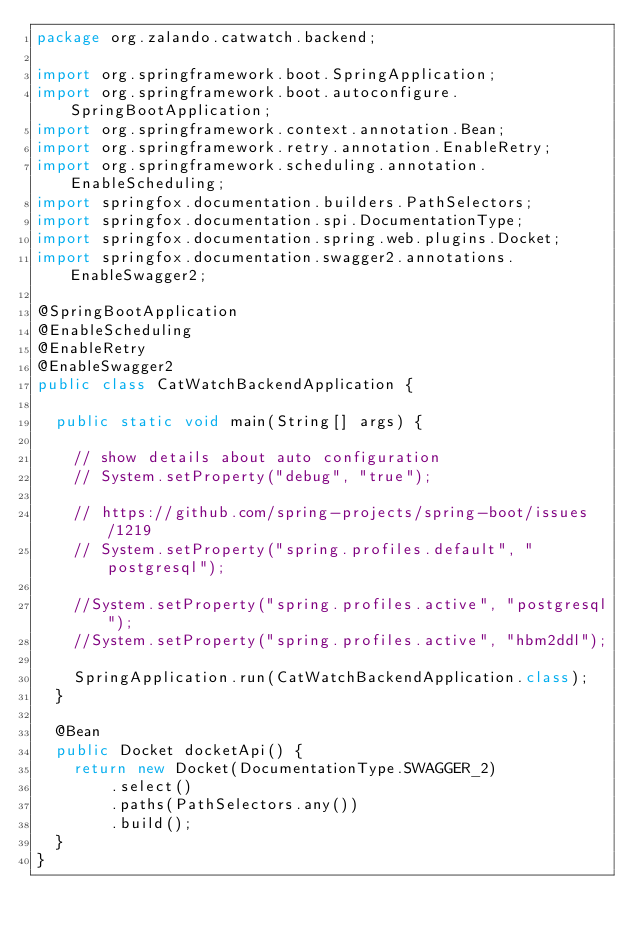<code> <loc_0><loc_0><loc_500><loc_500><_Java_>package org.zalando.catwatch.backend;

import org.springframework.boot.SpringApplication;
import org.springframework.boot.autoconfigure.SpringBootApplication;
import org.springframework.context.annotation.Bean;
import org.springframework.retry.annotation.EnableRetry;
import org.springframework.scheduling.annotation.EnableScheduling;
import springfox.documentation.builders.PathSelectors;
import springfox.documentation.spi.DocumentationType;
import springfox.documentation.spring.web.plugins.Docket;
import springfox.documentation.swagger2.annotations.EnableSwagger2;

@SpringBootApplication
@EnableScheduling
@EnableRetry
@EnableSwagger2
public class CatWatchBackendApplication {

	public static void main(String[] args) {

		// show details about auto configuration
		// System.setProperty("debug", "true");

		// https://github.com/spring-projects/spring-boot/issues/1219
		// System.setProperty("spring.profiles.default", "postgresql");

		//System.setProperty("spring.profiles.active", "postgresql");
		//System.setProperty("spring.profiles.active", "hbm2ddl");

		SpringApplication.run(CatWatchBackendApplication.class);
	}

	@Bean
	public Docket docketApi() {
		return new Docket(DocumentationType.SWAGGER_2)
				.select()
				.paths(PathSelectors.any())
				.build();
	}
}
</code> 